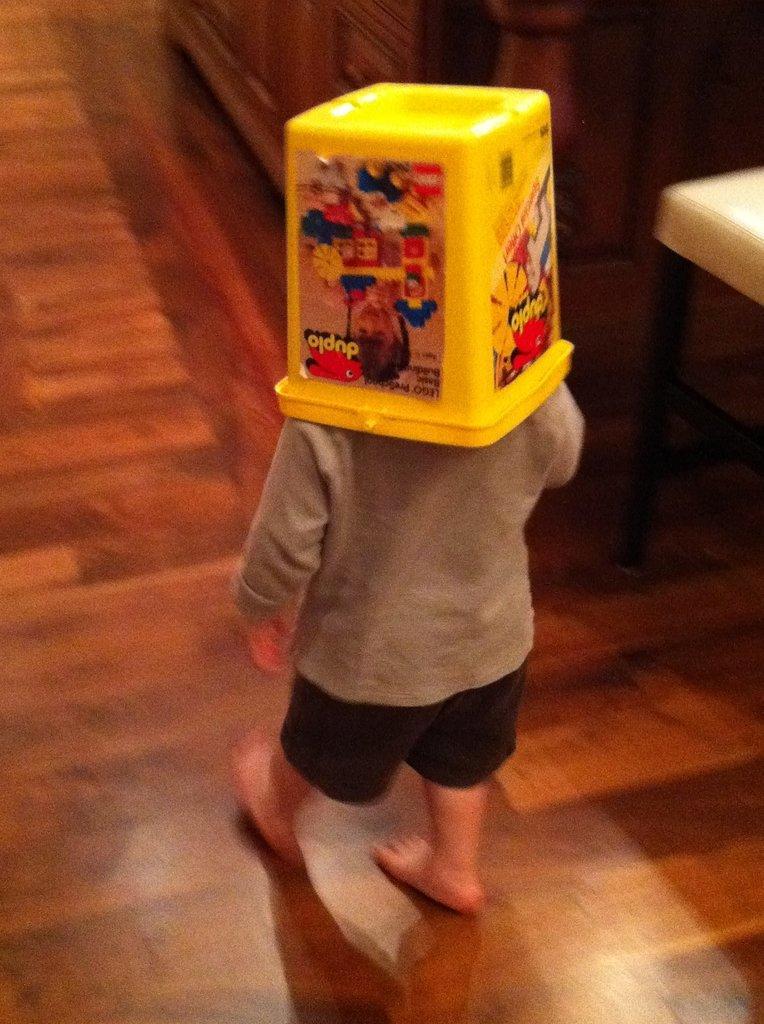Please provide a concise description of this image. In this image, we can see a kid is walking on a wooden floor and kept a yellow box on his head. Background we can see a cupboard. Right side of the image, there is a white table. 